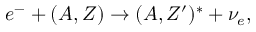Convert formula to latex. <formula><loc_0><loc_0><loc_500><loc_500>e ^ { - } + ( A , Z ) \rightarrow ( A , Z ^ { \prime } ) ^ { * } + \nu _ { e } ,</formula> 